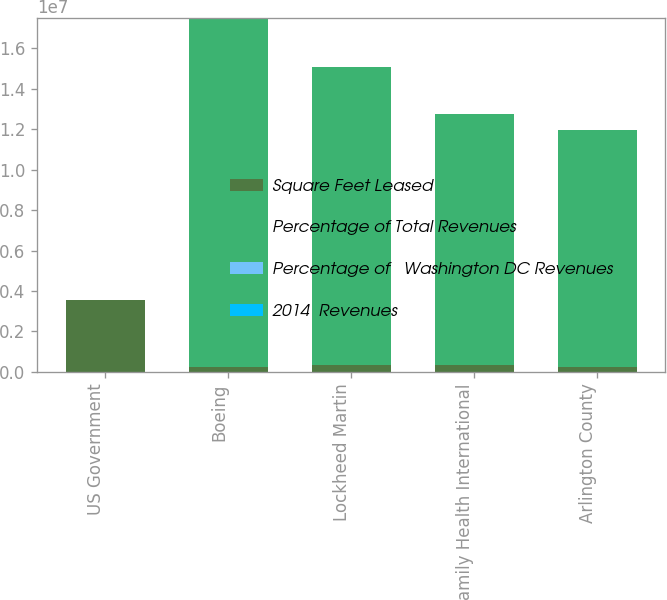<chart> <loc_0><loc_0><loc_500><loc_500><stacked_bar_chart><ecel><fcel>US Government<fcel>Boeing<fcel>Lockheed Martin<fcel>Family Health International<fcel>Arlington County<nl><fcel>Square Feet Leased<fcel>3.576e+06<fcel>253000<fcel>329000<fcel>359000<fcel>241000<nl><fcel>Percentage of Total Revenues<fcel>24.8<fcel>1.7249e+07<fcel>1.4755e+07<fcel>1.2407e+07<fcel>1.1728e+07<nl><fcel>Percentage of   Washington DC Revenues<fcel>24.8<fcel>3.2<fcel>2.8<fcel>2.3<fcel>2.2<nl><fcel>2014  Revenues<fcel>5<fcel>0.7<fcel>0.6<fcel>0.5<fcel>0.4<nl></chart> 